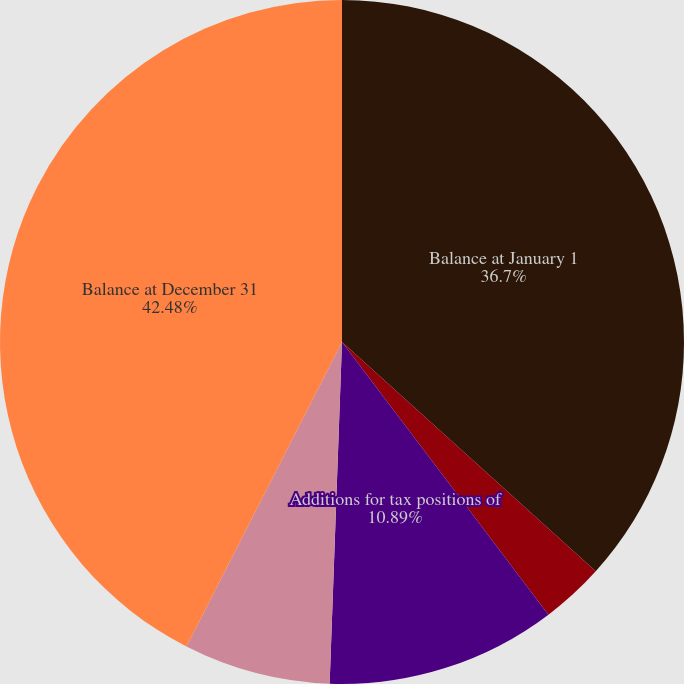Convert chart. <chart><loc_0><loc_0><loc_500><loc_500><pie_chart><fcel>Balance at January 1<fcel>Additions based on tax<fcel>Additions for tax positions of<fcel>Reductions for tax positions<fcel>Balance at December 31<nl><fcel>36.7%<fcel>2.99%<fcel>10.89%<fcel>6.94%<fcel>42.49%<nl></chart> 